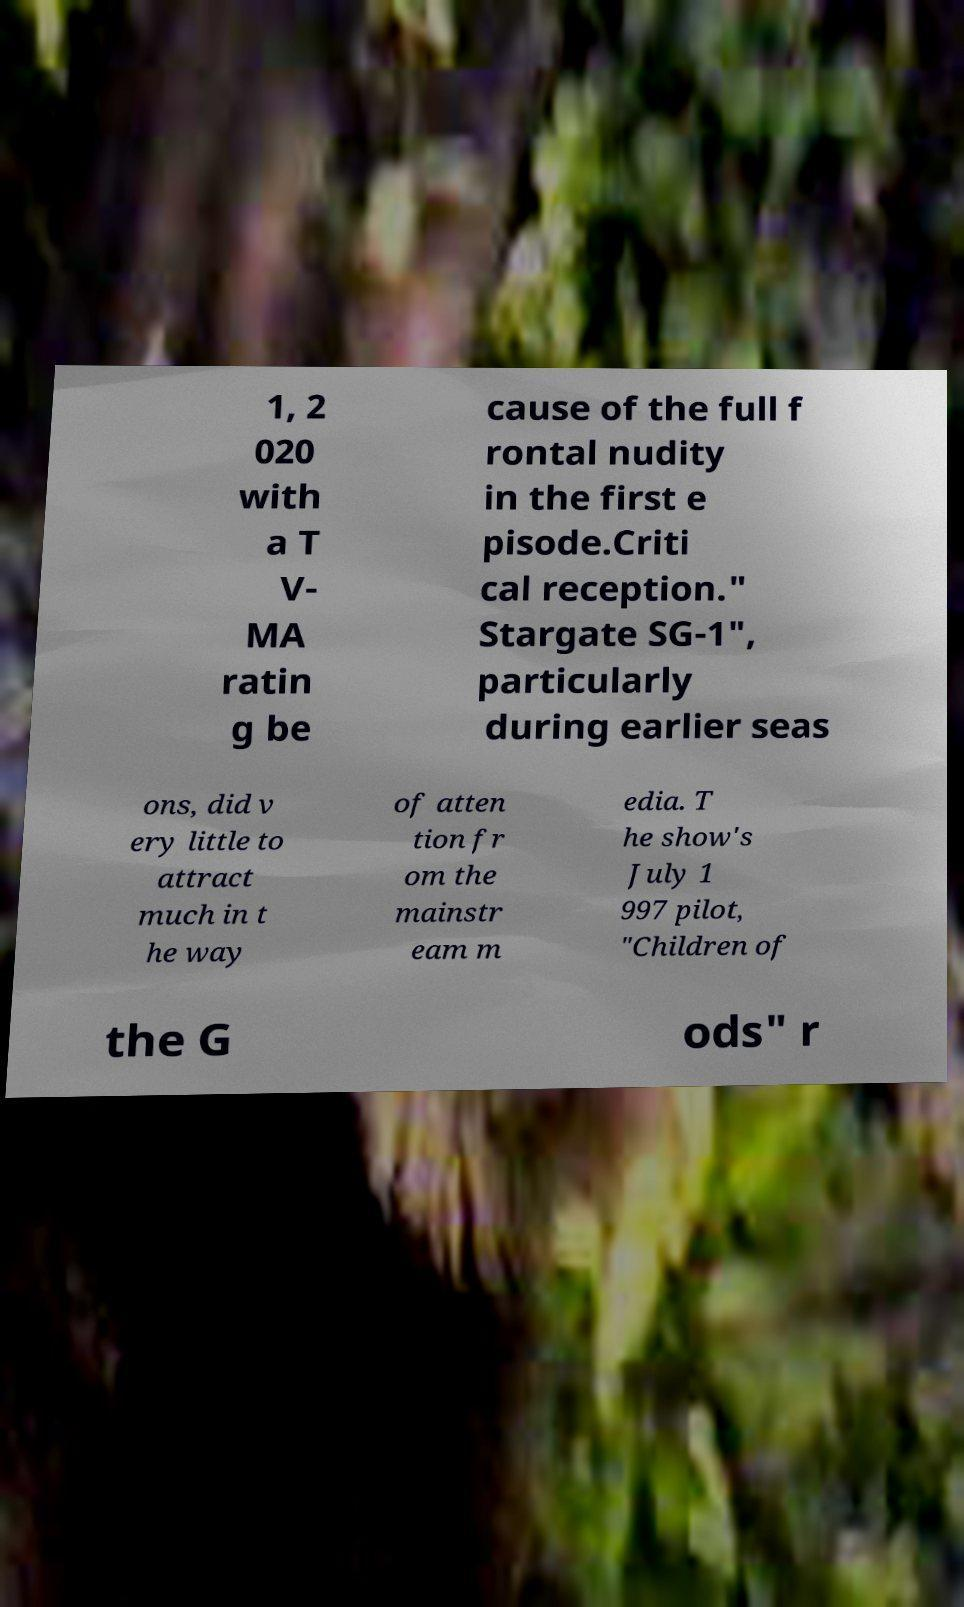Could you extract and type out the text from this image? 1, 2 020 with a T V- MA ratin g be cause of the full f rontal nudity in the first e pisode.Criti cal reception." Stargate SG-1", particularly during earlier seas ons, did v ery little to attract much in t he way of atten tion fr om the mainstr eam m edia. T he show's July 1 997 pilot, "Children of the G ods" r 